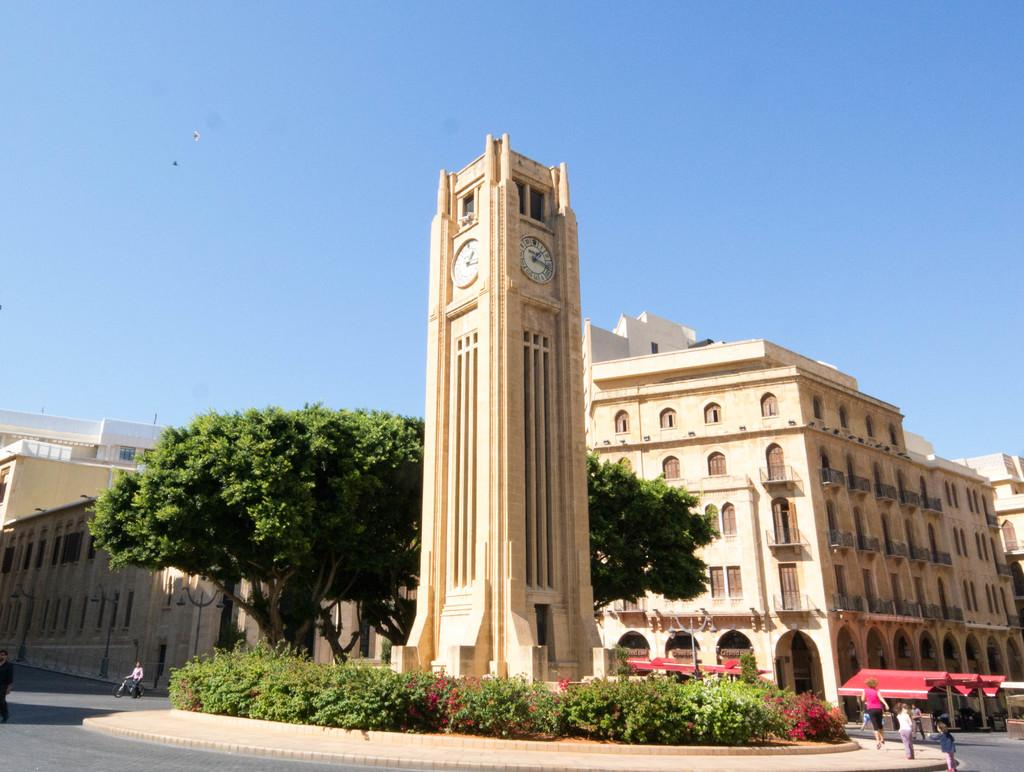<image>
Render a clear and concise summary of the photo. A street with a large clock tower that reads about 1:17. 